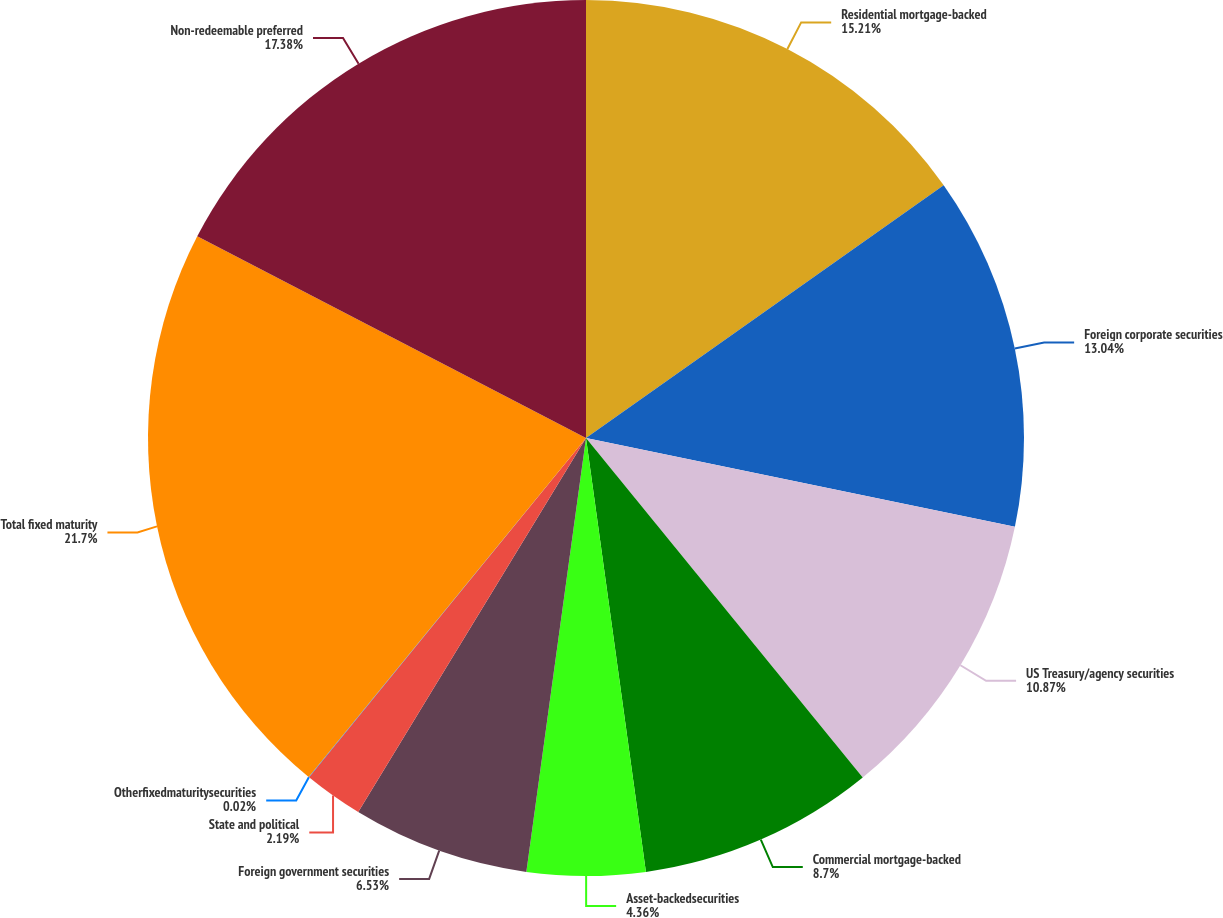Convert chart to OTSL. <chart><loc_0><loc_0><loc_500><loc_500><pie_chart><fcel>Residential mortgage-backed<fcel>Foreign corporate securities<fcel>US Treasury/agency securities<fcel>Commercial mortgage-backed<fcel>Asset-backedsecurities<fcel>Foreign government securities<fcel>State and political<fcel>Otherfixedmaturitysecurities<fcel>Total fixed maturity<fcel>Non-redeemable preferred<nl><fcel>15.21%<fcel>13.04%<fcel>10.87%<fcel>8.7%<fcel>4.36%<fcel>6.53%<fcel>2.19%<fcel>0.02%<fcel>21.71%<fcel>17.38%<nl></chart> 